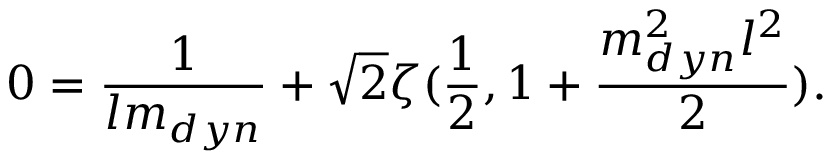Convert formula to latex. <formula><loc_0><loc_0><loc_500><loc_500>0 = \frac { 1 } { l m _ { d y n } } + \sqrt { 2 } \zeta ( \frac { 1 } { 2 } , 1 + \frac { m _ { d y n } ^ { 2 } l ^ { 2 } } { 2 } ) .</formula> 